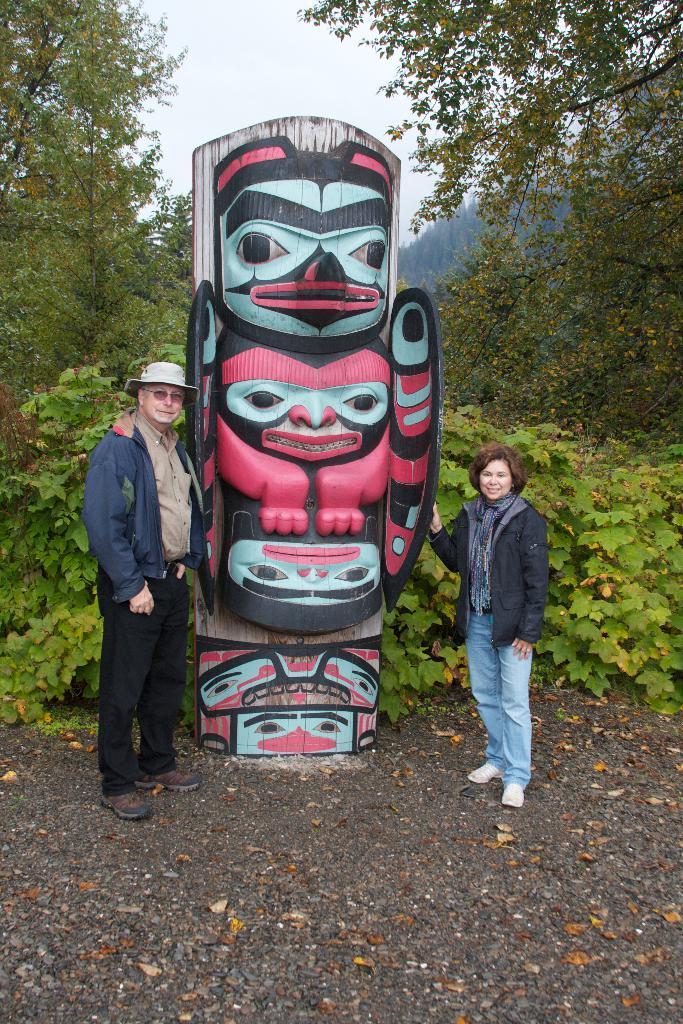In one or two sentences, can you explain what this image depicts? In this picture there is a wooden art statue with painted face mask. Beside there is a woman wearing blue color jacket, smiling and giving a pose into the camera. On the left side there is a another man wearing blue color jacket smiling and standing. Behind there are some green plants and trees. 